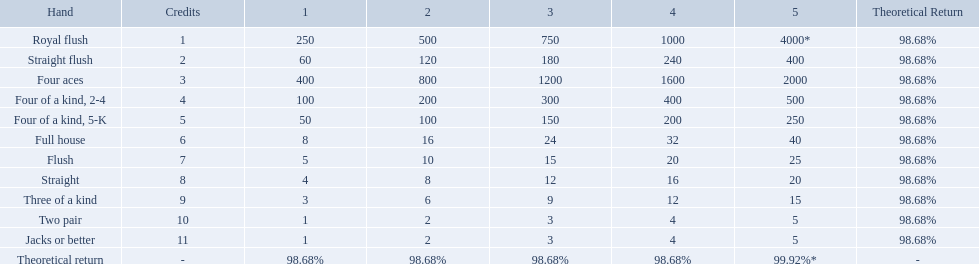What are the top 5 best types of hand for winning? Royal flush, Straight flush, Four aces, Four of a kind, 2-4, Four of a kind, 5-K. Between those 5, which of those hands are four of a kind? Four of a kind, 2-4, Four of a kind, 5-K. Of those 2 hands, which is the best kind of four of a kind for winning? Four of a kind, 2-4. 